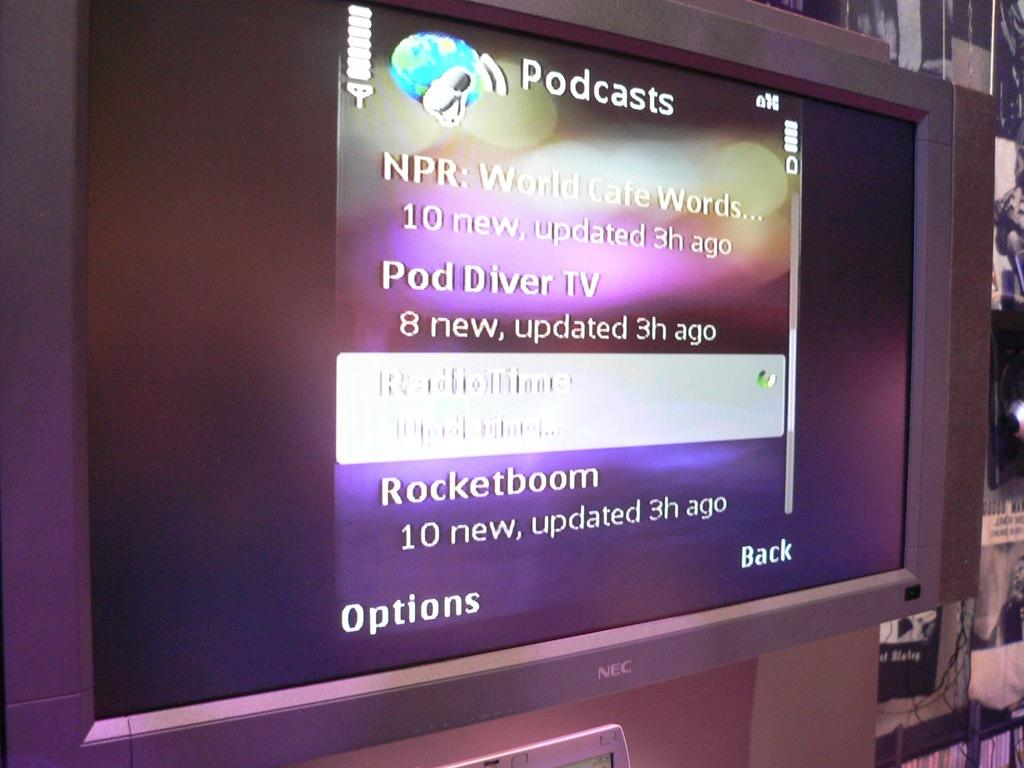<image>
Describe the image concisely. A screen shows a lists of podcasts on a purple background. 